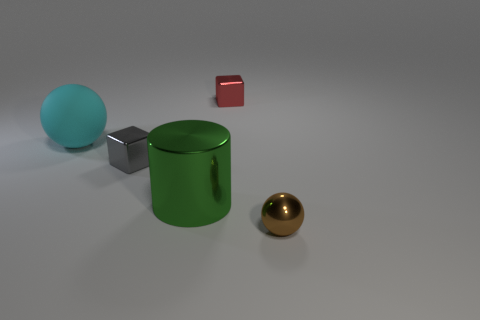Is there anything else that is made of the same material as the large ball?
Your answer should be compact. No. What is the object that is on the right side of the cube that is behind the sphere that is on the left side of the small brown thing made of?
Offer a terse response. Metal. What is the shape of the red shiny object that is the same size as the gray shiny cube?
Provide a succinct answer. Cube. What number of objects are either small green metallic blocks or things on the left side of the tiny red metallic cube?
Provide a succinct answer. 3. Is the large object that is left of the gray block made of the same material as the cube that is behind the tiny gray block?
Offer a very short reply. No. What number of red things are metallic cylinders or cubes?
Give a very brief answer. 1. The cyan matte sphere is what size?
Ensure brevity in your answer.  Large. Is the number of cyan rubber balls that are behind the red metal object greater than the number of small gray objects?
Make the answer very short. No. There is a big matte object; how many big green cylinders are right of it?
Provide a succinct answer. 1. Are there any yellow spheres of the same size as the brown shiny ball?
Ensure brevity in your answer.  No. 